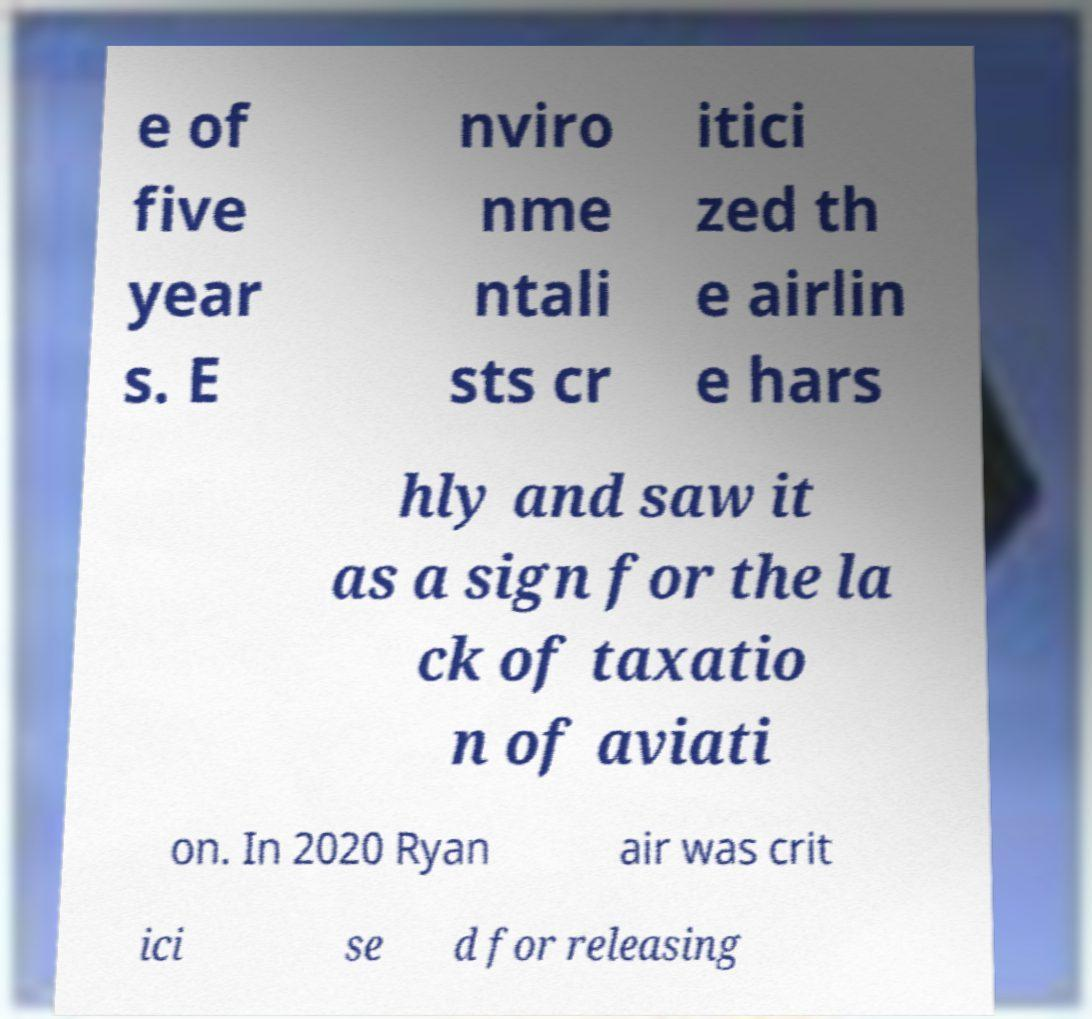I need the written content from this picture converted into text. Can you do that? e of five year s. E nviro nme ntali sts cr itici zed th e airlin e hars hly and saw it as a sign for the la ck of taxatio n of aviati on. In 2020 Ryan air was crit ici se d for releasing 